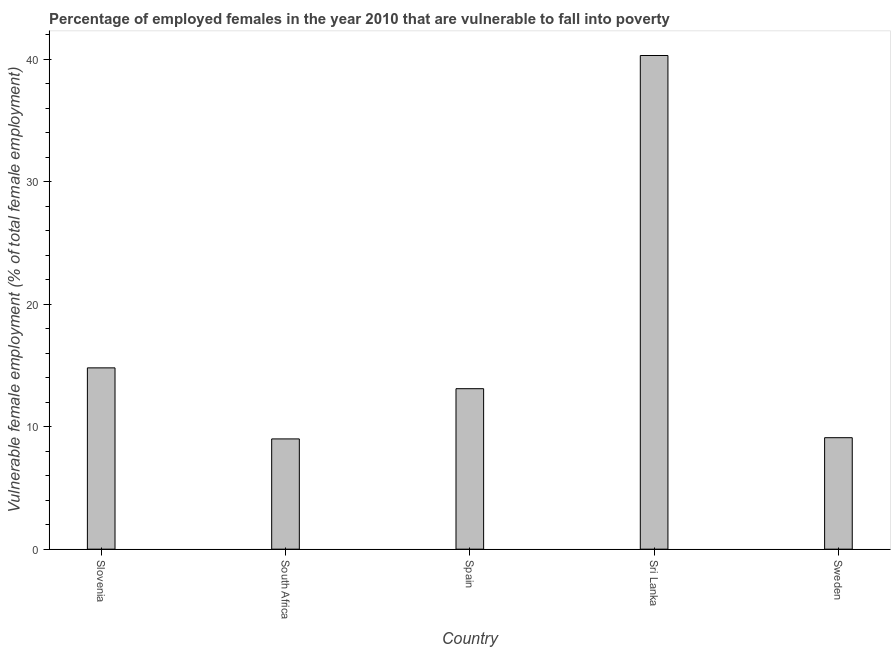What is the title of the graph?
Your answer should be compact. Percentage of employed females in the year 2010 that are vulnerable to fall into poverty. What is the label or title of the X-axis?
Offer a terse response. Country. What is the label or title of the Y-axis?
Keep it short and to the point. Vulnerable female employment (% of total female employment). What is the percentage of employed females who are vulnerable to fall into poverty in Sweden?
Offer a terse response. 9.1. Across all countries, what is the maximum percentage of employed females who are vulnerable to fall into poverty?
Offer a terse response. 40.3. In which country was the percentage of employed females who are vulnerable to fall into poverty maximum?
Provide a short and direct response. Sri Lanka. In which country was the percentage of employed females who are vulnerable to fall into poverty minimum?
Offer a terse response. South Africa. What is the sum of the percentage of employed females who are vulnerable to fall into poverty?
Offer a terse response. 86.3. What is the difference between the percentage of employed females who are vulnerable to fall into poverty in South Africa and Spain?
Offer a terse response. -4.1. What is the average percentage of employed females who are vulnerable to fall into poverty per country?
Make the answer very short. 17.26. What is the median percentage of employed females who are vulnerable to fall into poverty?
Your answer should be very brief. 13.1. What is the ratio of the percentage of employed females who are vulnerable to fall into poverty in Sri Lanka to that in Sweden?
Your answer should be very brief. 4.43. Is the difference between the percentage of employed females who are vulnerable to fall into poverty in South Africa and Sri Lanka greater than the difference between any two countries?
Ensure brevity in your answer.  Yes. What is the difference between the highest and the second highest percentage of employed females who are vulnerable to fall into poverty?
Ensure brevity in your answer.  25.5. What is the difference between the highest and the lowest percentage of employed females who are vulnerable to fall into poverty?
Provide a short and direct response. 31.3. In how many countries, is the percentage of employed females who are vulnerable to fall into poverty greater than the average percentage of employed females who are vulnerable to fall into poverty taken over all countries?
Provide a succinct answer. 1. Are all the bars in the graph horizontal?
Offer a terse response. No. What is the Vulnerable female employment (% of total female employment) of Slovenia?
Provide a short and direct response. 14.8. What is the Vulnerable female employment (% of total female employment) in South Africa?
Offer a very short reply. 9. What is the Vulnerable female employment (% of total female employment) of Spain?
Your answer should be compact. 13.1. What is the Vulnerable female employment (% of total female employment) of Sri Lanka?
Provide a succinct answer. 40.3. What is the Vulnerable female employment (% of total female employment) in Sweden?
Ensure brevity in your answer.  9.1. What is the difference between the Vulnerable female employment (% of total female employment) in Slovenia and South Africa?
Provide a short and direct response. 5.8. What is the difference between the Vulnerable female employment (% of total female employment) in Slovenia and Spain?
Keep it short and to the point. 1.7. What is the difference between the Vulnerable female employment (% of total female employment) in Slovenia and Sri Lanka?
Your answer should be very brief. -25.5. What is the difference between the Vulnerable female employment (% of total female employment) in Slovenia and Sweden?
Your response must be concise. 5.7. What is the difference between the Vulnerable female employment (% of total female employment) in South Africa and Sri Lanka?
Provide a succinct answer. -31.3. What is the difference between the Vulnerable female employment (% of total female employment) in Spain and Sri Lanka?
Offer a very short reply. -27.2. What is the difference between the Vulnerable female employment (% of total female employment) in Spain and Sweden?
Provide a short and direct response. 4. What is the difference between the Vulnerable female employment (% of total female employment) in Sri Lanka and Sweden?
Ensure brevity in your answer.  31.2. What is the ratio of the Vulnerable female employment (% of total female employment) in Slovenia to that in South Africa?
Offer a terse response. 1.64. What is the ratio of the Vulnerable female employment (% of total female employment) in Slovenia to that in Spain?
Offer a very short reply. 1.13. What is the ratio of the Vulnerable female employment (% of total female employment) in Slovenia to that in Sri Lanka?
Keep it short and to the point. 0.37. What is the ratio of the Vulnerable female employment (% of total female employment) in Slovenia to that in Sweden?
Provide a short and direct response. 1.63. What is the ratio of the Vulnerable female employment (% of total female employment) in South Africa to that in Spain?
Provide a short and direct response. 0.69. What is the ratio of the Vulnerable female employment (% of total female employment) in South Africa to that in Sri Lanka?
Provide a short and direct response. 0.22. What is the ratio of the Vulnerable female employment (% of total female employment) in Spain to that in Sri Lanka?
Offer a very short reply. 0.33. What is the ratio of the Vulnerable female employment (% of total female employment) in Spain to that in Sweden?
Give a very brief answer. 1.44. What is the ratio of the Vulnerable female employment (% of total female employment) in Sri Lanka to that in Sweden?
Ensure brevity in your answer.  4.43. 